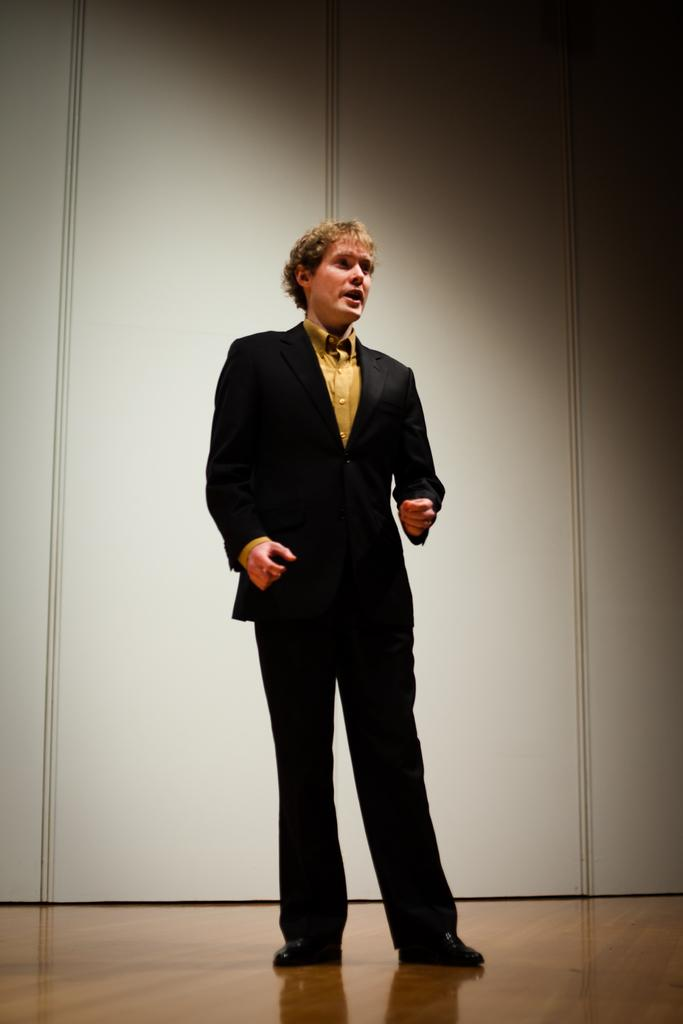Who or what is present in the image? There is a person in the image. What is the person wearing? The person is wearing a suit. What type of surface is the person standing on? The person is standing on a wooden floor. What can be seen behind the person? There is a wall visible behind the person. What mark can be seen on the person's wrist in the image? There is no mark visible on the person's wrist in the image. 